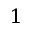<formula> <loc_0><loc_0><loc_500><loc_500>^ { 1 }</formula> 